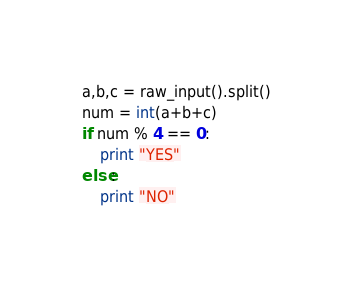Convert code to text. <code><loc_0><loc_0><loc_500><loc_500><_Python_>a,b,c = raw_input().split()
num = int(a+b+c)
if num % 4 == 0:
    print "YES"
else:
    print "NO"</code> 